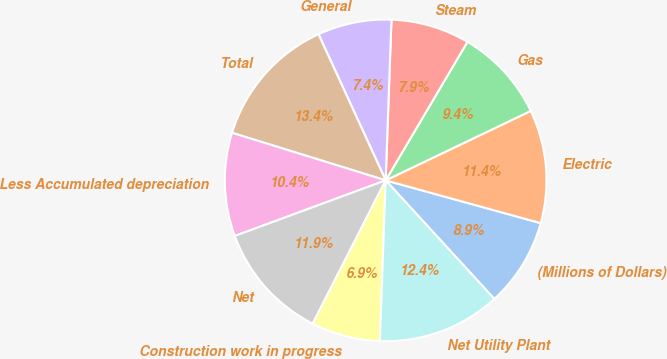Convert chart. <chart><loc_0><loc_0><loc_500><loc_500><pie_chart><fcel>(Millions of Dollars)<fcel>Electric<fcel>Gas<fcel>Steam<fcel>General<fcel>Total<fcel>Less Accumulated depreciation<fcel>Net<fcel>Construction work in progress<fcel>Net Utility Plant<nl><fcel>8.91%<fcel>11.39%<fcel>9.41%<fcel>7.92%<fcel>7.43%<fcel>13.37%<fcel>10.4%<fcel>11.88%<fcel>6.93%<fcel>12.38%<nl></chart> 